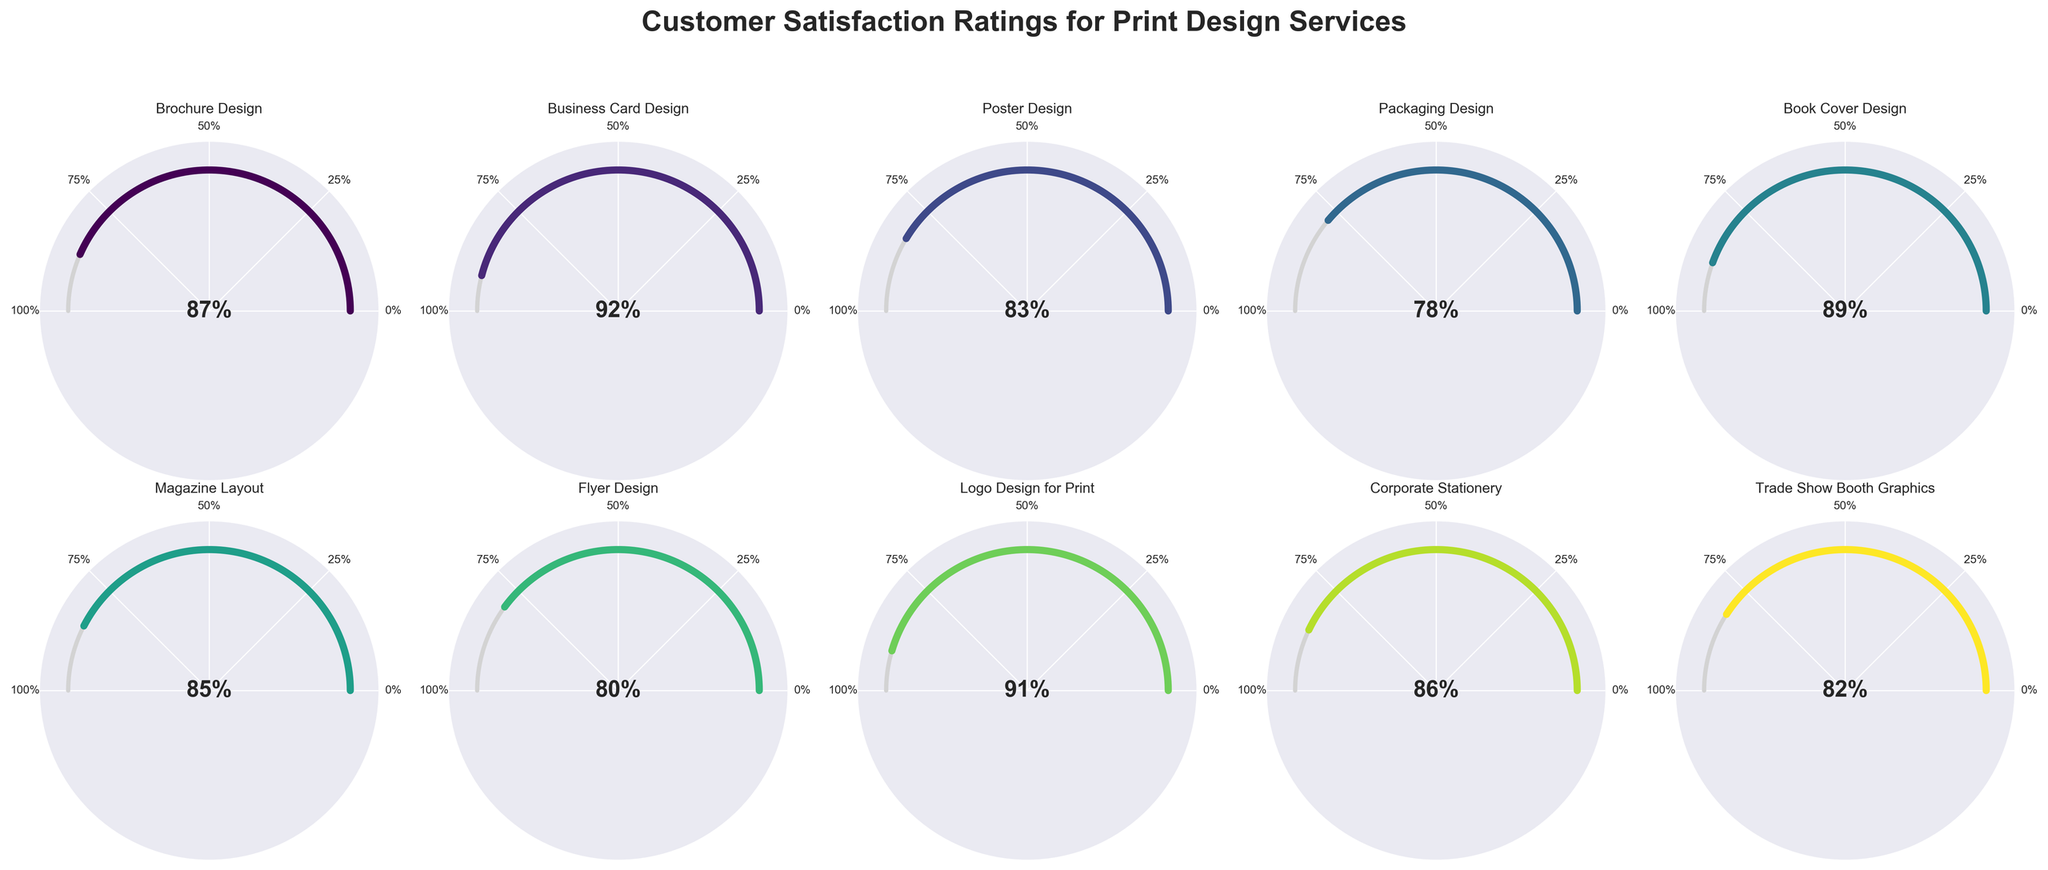what is the satisfaction rating for Brochure Design? Look at the gauge labeled 'Brochure Design'. The gauge points to 87 and has text that displays '87%'.
Answer: 87% Which print design service has the highest customer satisfaction? By comparing the endpoints of all gauges, we find that the 'Business Card Design' gauge is the farthest along, pointing to 92.
Answer: Business Card Design How many services have a satisfaction rating above 85%? Count the number of gauges pointing above the 85 mark. The services are Brochure Design (87), Business Card Design (92), Book Cover Design (89), Magazine Layout (85), and Logo Design for Print (91).
Answer: 5 What is the average satisfaction rating for Packaging Design and Flyer Design? Sum the satisfaction ratings for Packaging Design (78) and Flyer Design (80), then divide by 2. (78 + 80) / 2 = 79
Answer: 79 Which service has a higher satisfaction rating: Trade Show Booth Graphics or Poster Design? Compare the satisfaction ratings directly: Trade Show Booth Graphics (82) and Poster Design (83). Poster Design has a higher rating.
Answer: Poster Design What is the range of satisfaction ratings displayed by the gauges? Find the highest rating (Business Card Design at 92) and the lowest rating (Packaging Design at 78), then calculate the range: 92 - 78 = 14.
Answer: 14 What is the median satisfaction rating of all services? List out all satisfaction ratings: 87, 92, 83, 78, 89, 85, 80, 91, 86, 82. Sort them: 78, 80, 82, 83, 85, 86, 87, 89, 91, 92. The middle values are 85 and 86, so the median is (85 + 86) / 2 = 85.5.
Answer: 85.5 Which service has a satisfaction rating closest to 85%? Compare the given ratings to 85 and find the closest one. Magazine Layout has exactly 85%.
Answer: Magazine Layout What's the difference between the highest and lowest satisfaction ratings? Subtract the lowest rating (78 for Packaging Design) from the highest rating (92 for Business Card Design): 92 - 78 = 14.
Answer: 14 What’s the combined satisfaction rating for Logo Design for Print and Corporate Stationery? Add the ratings for Logo Design for Print (91) and Corporate Stationery (86): 91 + 86 = 177.
Answer: 177 